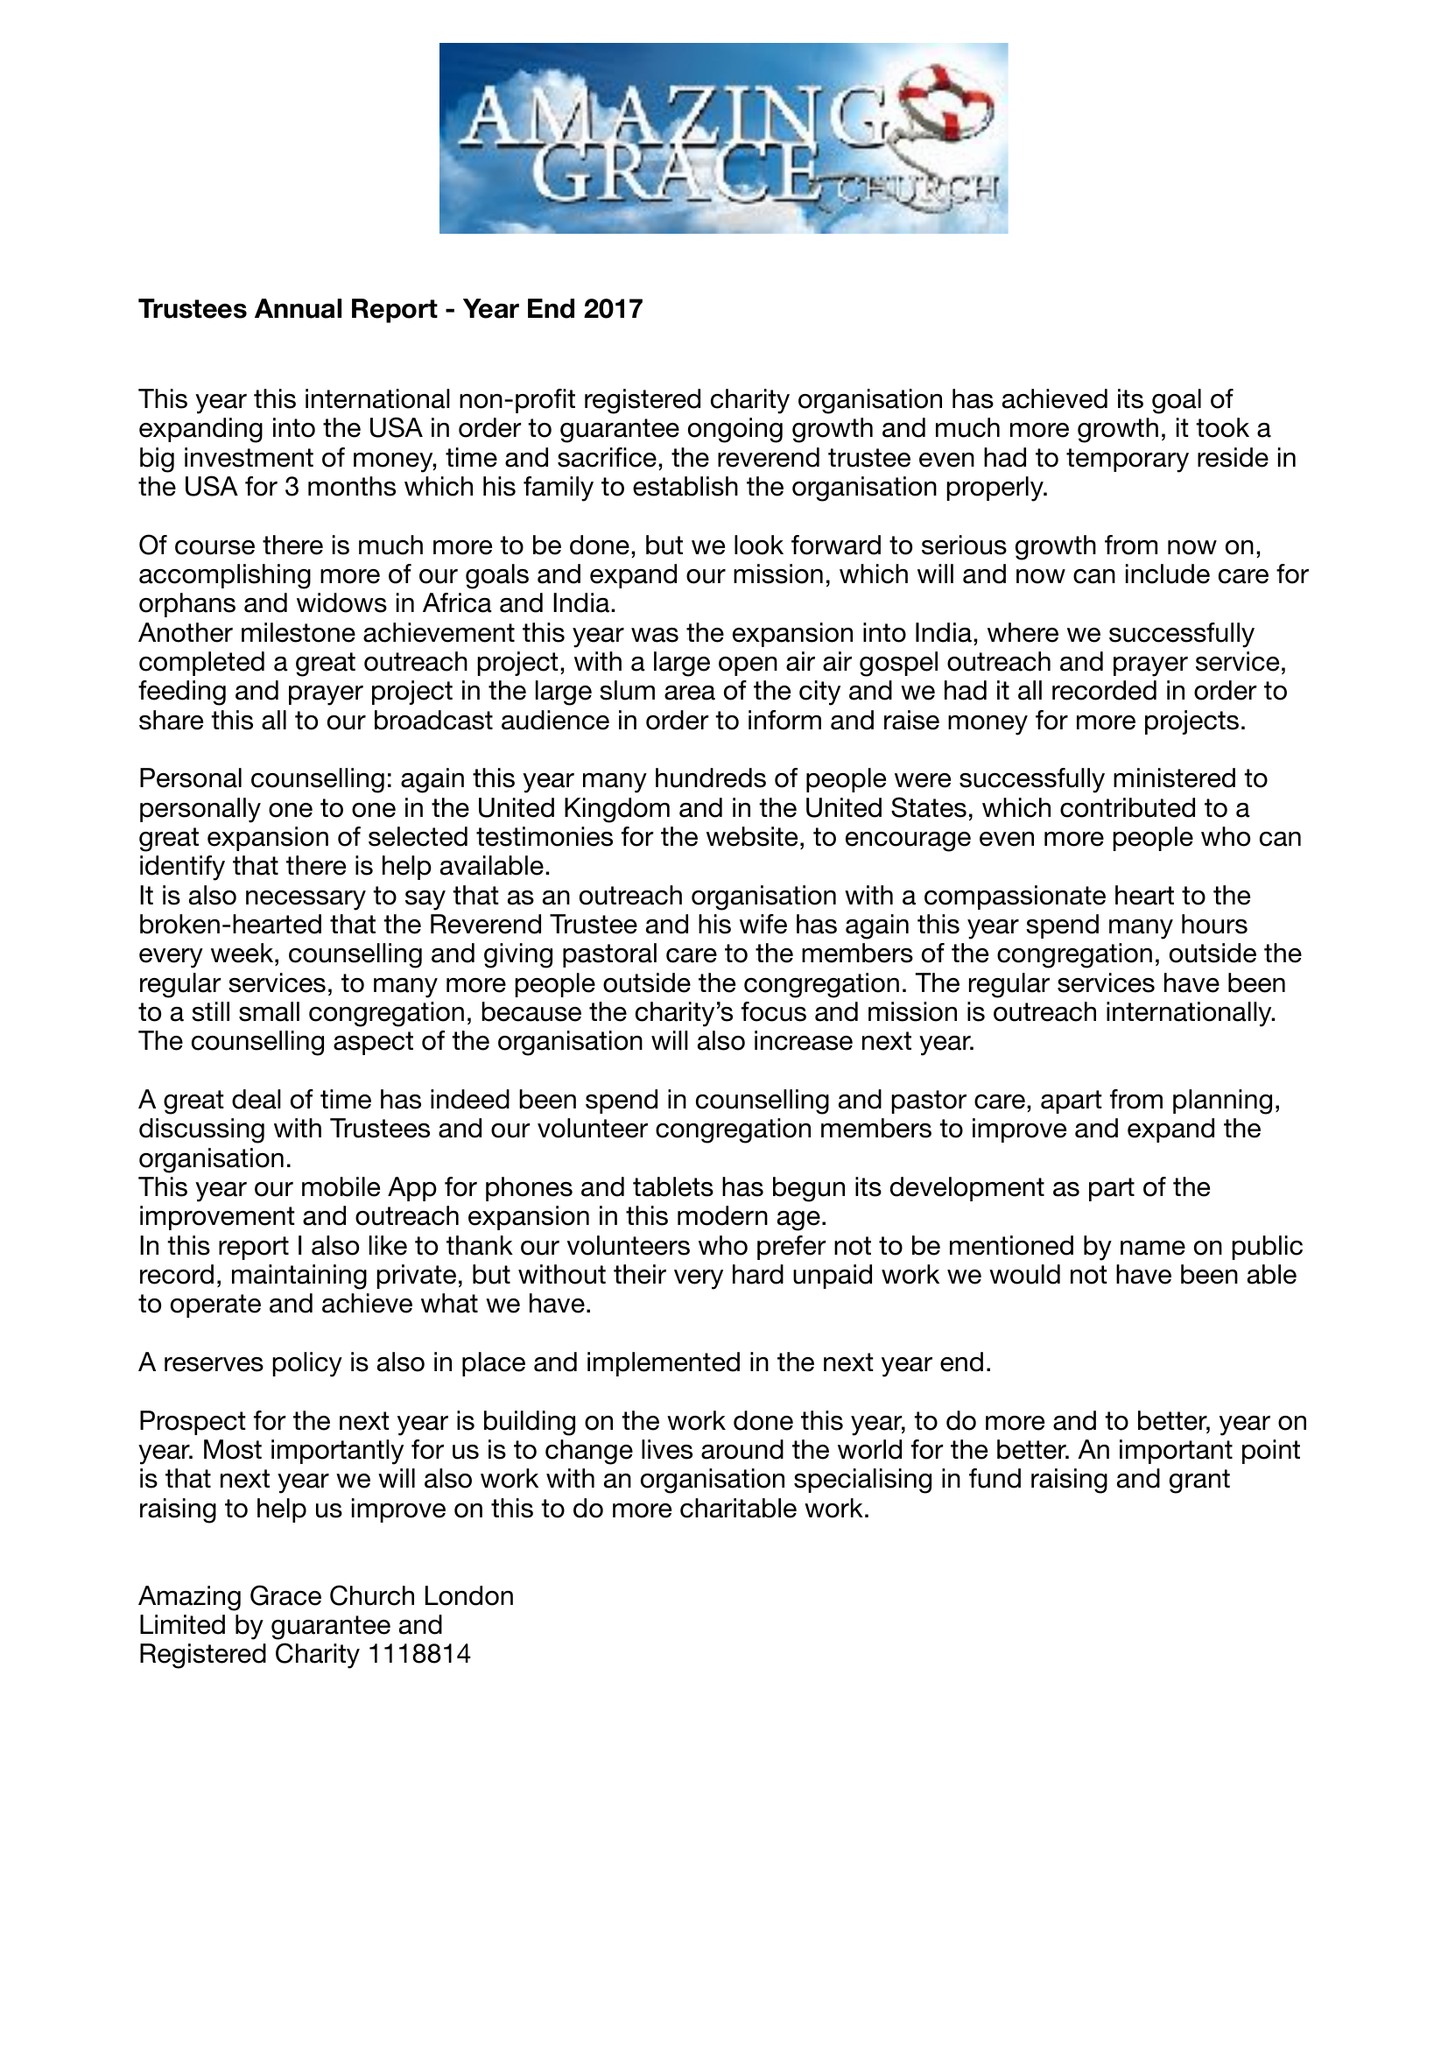What is the value for the spending_annually_in_british_pounds?
Answer the question using a single word or phrase. 78091.00 